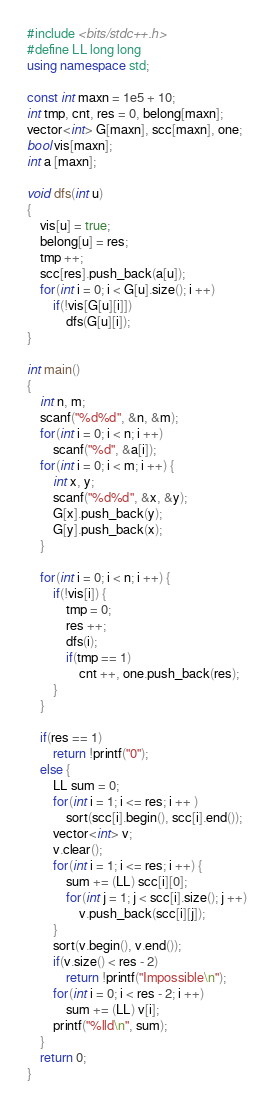Convert code to text. <code><loc_0><loc_0><loc_500><loc_500><_C++_>#include <bits/stdc++.h>
#define LL long long
using namespace std;

const int maxn = 1e5 + 10;
int tmp, cnt, res = 0, belong[maxn];
vector<int> G[maxn], scc[maxn], one;
bool vis[maxn];
int a [maxn];

void dfs(int u)
{
    vis[u] = true;
    belong[u] = res;
    tmp ++;
    scc[res].push_back(a[u]);
    for(int i = 0; i < G[u].size(); i ++)
        if(!vis[G[u][i]])
            dfs(G[u][i]);
}

int main()
{
    int n, m;
    scanf("%d%d", &n, &m);
    for(int i = 0; i < n; i ++)
        scanf("%d", &a[i]);
    for(int i = 0; i < m; i ++) {
        int x, y;
        scanf("%d%d", &x, &y);
        G[x].push_back(y);
        G[y].push_back(x);
    }

    for(int i = 0; i < n; i ++) {
        if(!vis[i]) {
            tmp = 0;
            res ++;
            dfs(i);
            if(tmp == 1)
                cnt ++, one.push_back(res);
        }
    }

    if(res == 1)
        return !printf("0");
    else {
        LL sum = 0;
        for(int i = 1; i <= res; i ++ )
            sort(scc[i].begin(), scc[i].end());
        vector<int> v;
        v.clear();
        for(int i = 1; i <= res; i ++) {
            sum += (LL) scc[i][0];
            for(int j = 1; j < scc[i].size(); j ++)
                v.push_back(scc[i][j]);
        }
        sort(v.begin(), v.end());
        if(v.size() < res - 2)
            return !printf("Impossible\n");
        for(int i = 0; i < res - 2; i ++)
            sum += (LL) v[i];
        printf("%lld\n", sum);
    }
    return 0;
}
</code> 